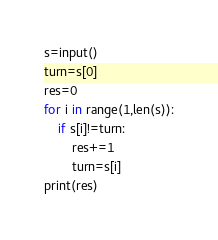Convert code to text. <code><loc_0><loc_0><loc_500><loc_500><_Python_>s=input()
turn=s[0]
res=0
for i in range(1,len(s)):
    if s[i]!=turn:
        res+=1
        turn=s[i]
print(res)</code> 